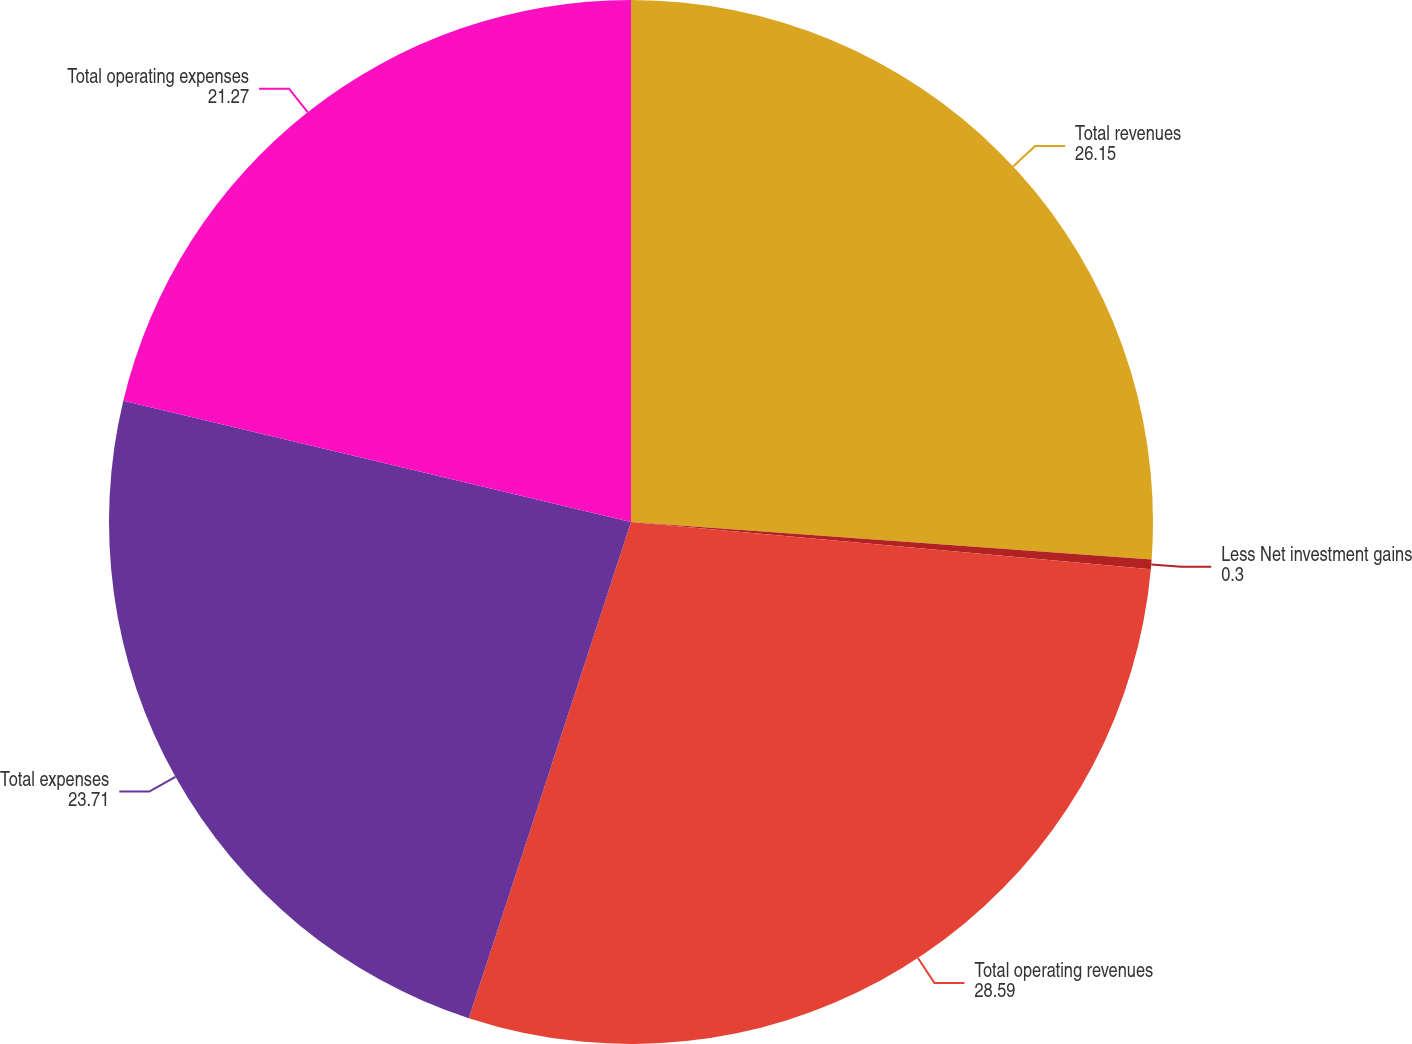<chart> <loc_0><loc_0><loc_500><loc_500><pie_chart><fcel>Total revenues<fcel>Less Net investment gains<fcel>Total operating revenues<fcel>Total expenses<fcel>Total operating expenses<nl><fcel>26.15%<fcel>0.3%<fcel>28.59%<fcel>23.71%<fcel>21.27%<nl></chart> 